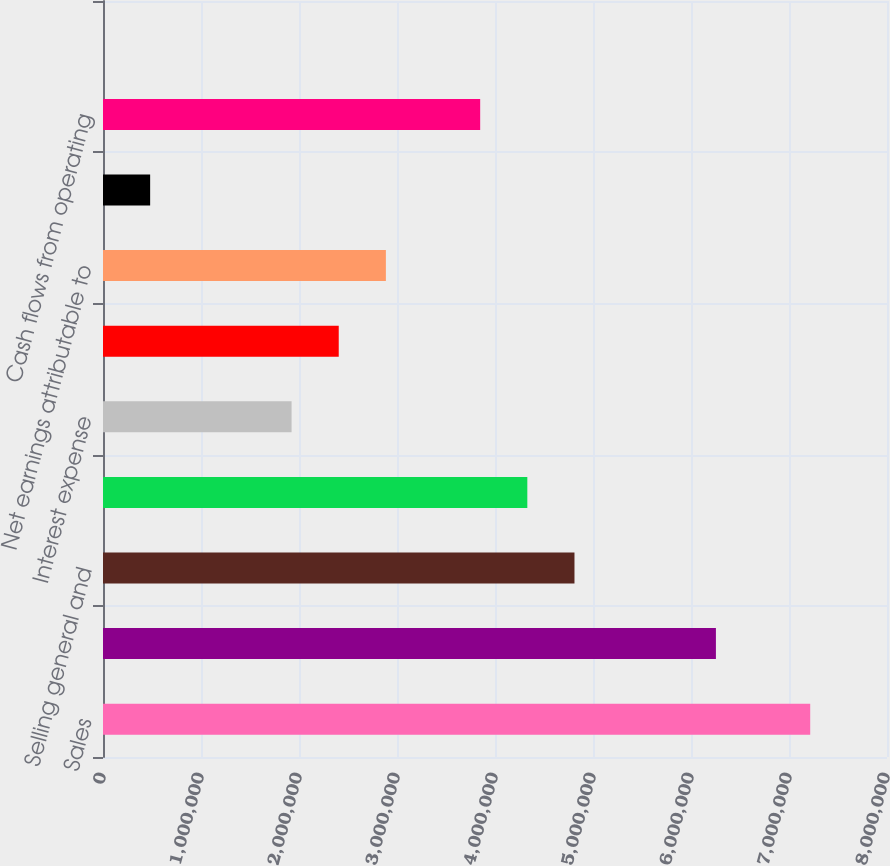<chart> <loc_0><loc_0><loc_500><loc_500><bar_chart><fcel>Sales<fcel>Gross profit<fcel>Selling general and<fcel>Operating income<fcel>Interest expense<fcel>Provision for income taxes<fcel>Net earnings attributable to<fcel>Net earnings per share of<fcel>Cash flows from operating<fcel>Cash dividends declared per<nl><fcel>7.21644e+06<fcel>6.25425e+06<fcel>4.81096e+06<fcel>4.32986e+06<fcel>1.92438e+06<fcel>2.40548e+06<fcel>2.88657e+06<fcel>481096<fcel>3.84877e+06<fcel>0.48<nl></chart> 